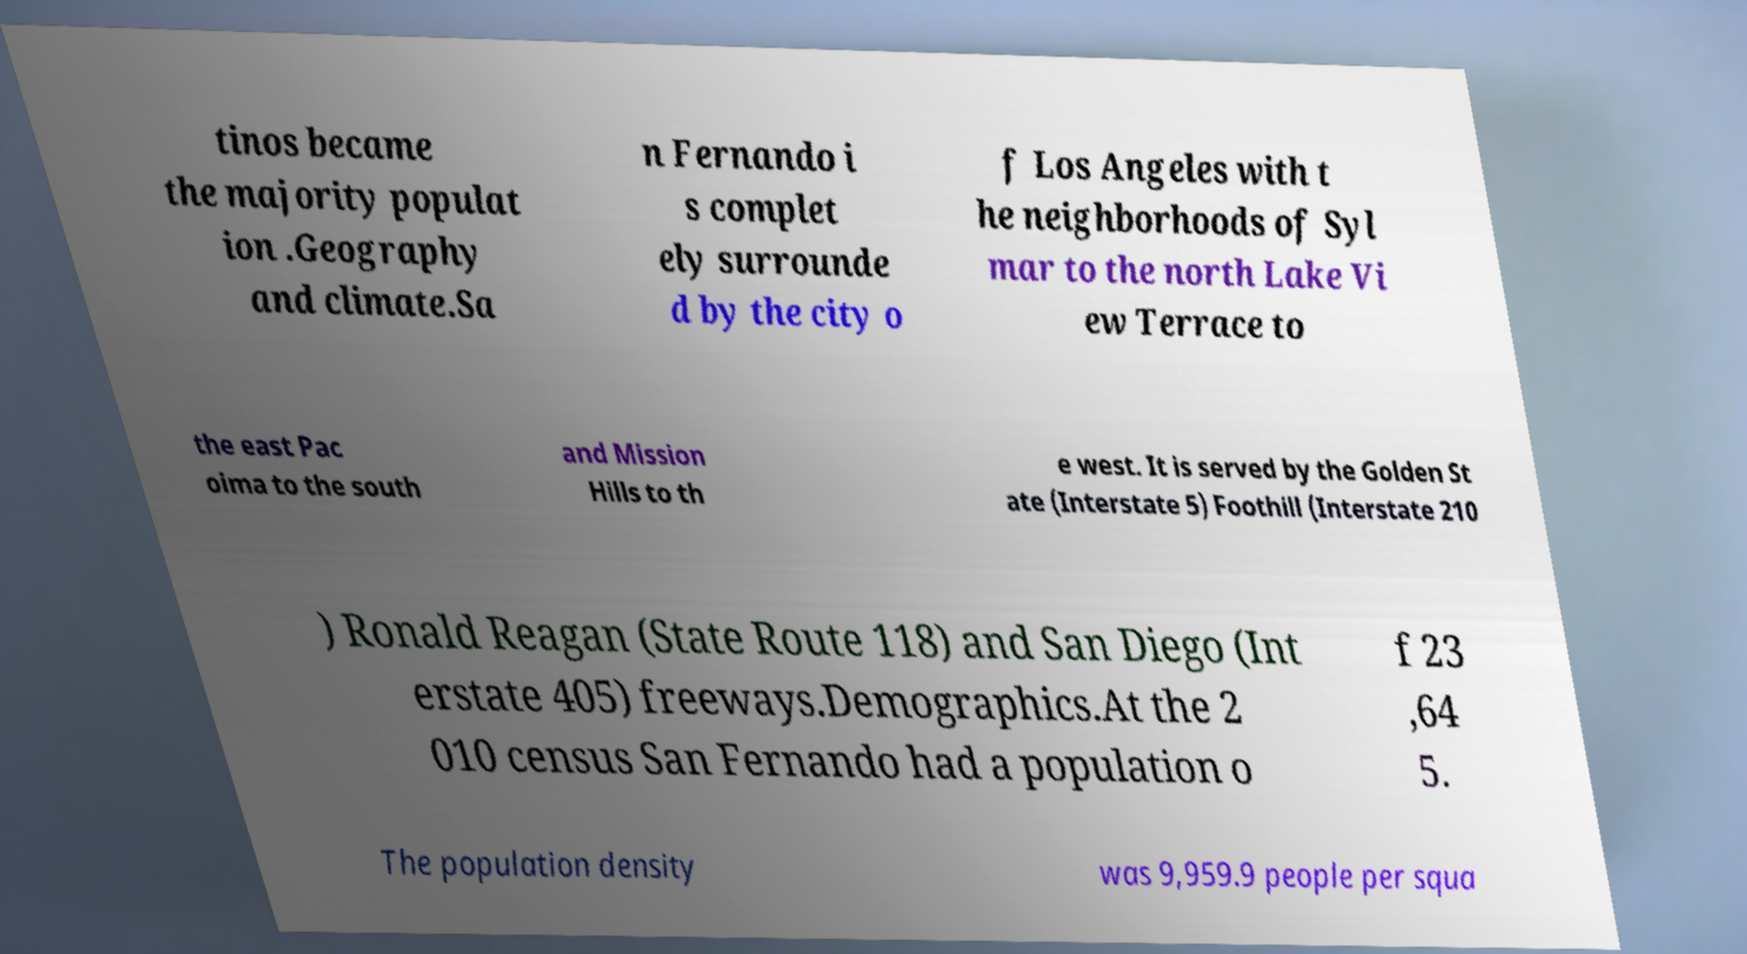There's text embedded in this image that I need extracted. Can you transcribe it verbatim? tinos became the majority populat ion .Geography and climate.Sa n Fernando i s complet ely surrounde d by the city o f Los Angeles with t he neighborhoods of Syl mar to the north Lake Vi ew Terrace to the east Pac oima to the south and Mission Hills to th e west. It is served by the Golden St ate (Interstate 5) Foothill (Interstate 210 ) Ronald Reagan (State Route 118) and San Diego (Int erstate 405) freeways.Demographics.At the 2 010 census San Fernando had a population o f 23 ,64 5. The population density was 9,959.9 people per squa 